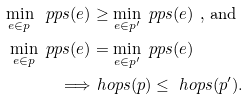<formula> <loc_0><loc_0><loc_500><loc_500>\min _ { e \in p } \ p p s ( e ) & \geq \min _ { e \in p ^ { \prime } } \ p p s ( e ) \text { , and} \\ \min _ { e \in p } \ p p s ( e ) & = \min _ { e \in p ^ { \prime } } \ p p s ( e ) \\ \Longrightarrow & \ h o p s ( p ) \leq \ h o p s ( p ^ { \prime } ) .</formula> 